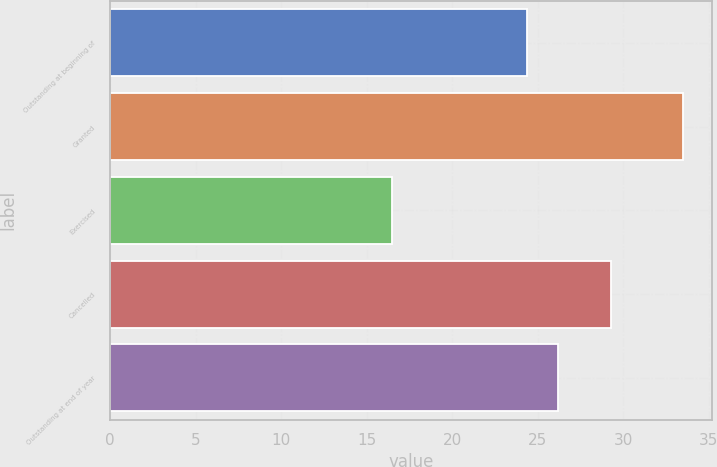Convert chart to OTSL. <chart><loc_0><loc_0><loc_500><loc_500><bar_chart><fcel>Outstanding at beginning of<fcel>Granted<fcel>Exercised<fcel>Cancelled<fcel>Outstanding at end of year<nl><fcel>24.41<fcel>33.52<fcel>16.46<fcel>29.29<fcel>26.19<nl></chart> 